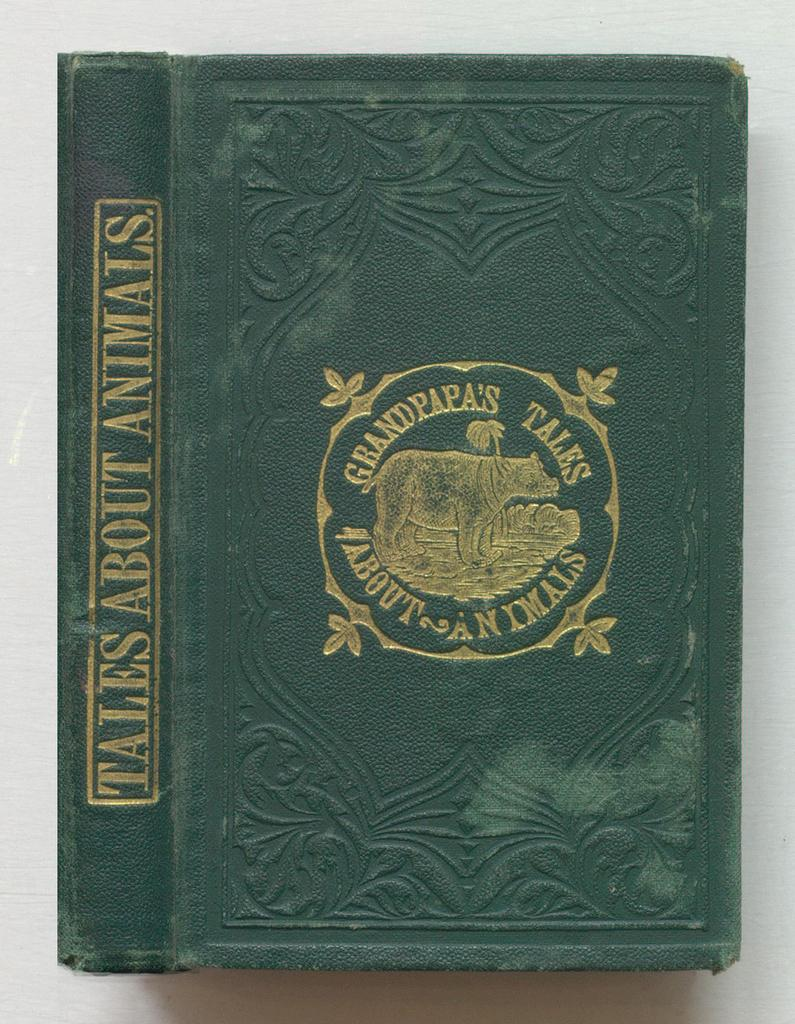<image>
Summarize the visual content of the image. An old green book about animals has gold embossing. 